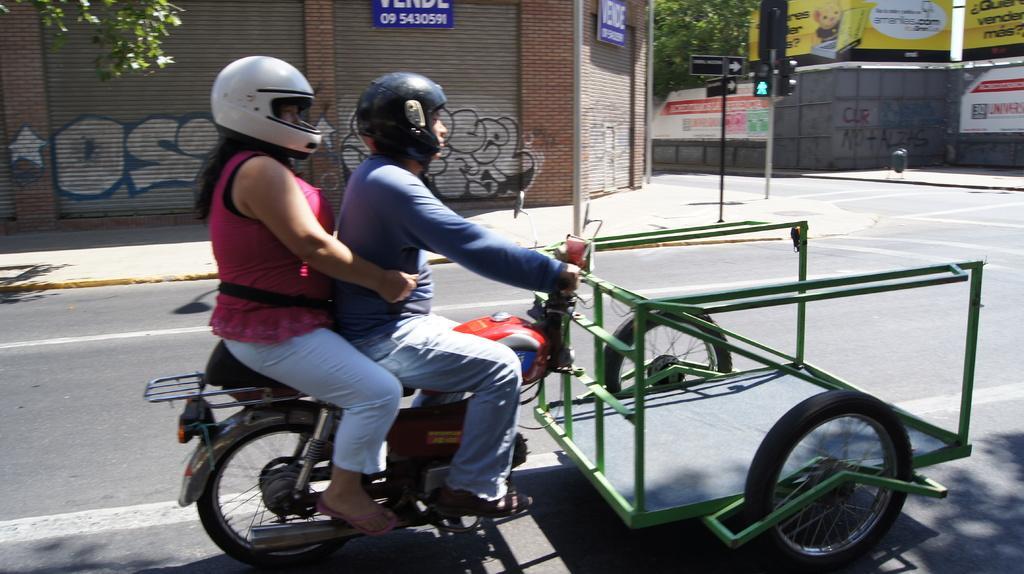In one or two sentences, can you explain what this image depicts? In the picture we can see a woman and a man sitting on the bike, man is riding the bike, and the bike is three wheeler and in front of the bike is connected with trolley and they are wearing helmets and behind them we can see some shutters and beside it we can see some poles with traffic lights and behind it we can see a wall and behind it we can see a tree. 